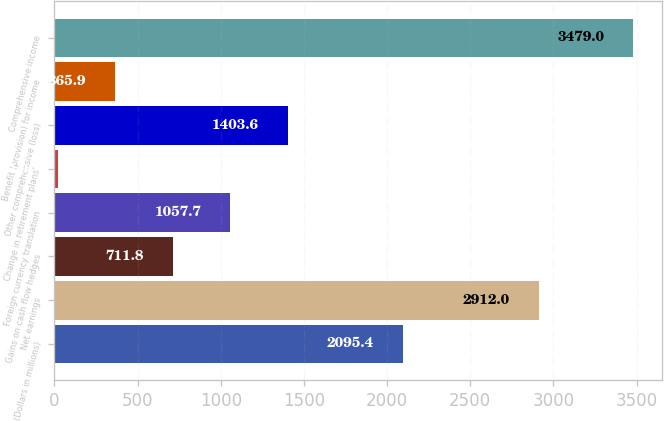Convert chart to OTSL. <chart><loc_0><loc_0><loc_500><loc_500><bar_chart><fcel>(Dollars in millions)<fcel>Net earnings<fcel>Gains on cash flow hedges<fcel>Foreign currency translation<fcel>Change in retirement plans'<fcel>Other comprehensive (loss)<fcel>Benefit (provision) for income<fcel>Comprehensive income<nl><fcel>2095.4<fcel>2912<fcel>711.8<fcel>1057.7<fcel>20<fcel>1403.6<fcel>365.9<fcel>3479<nl></chart> 